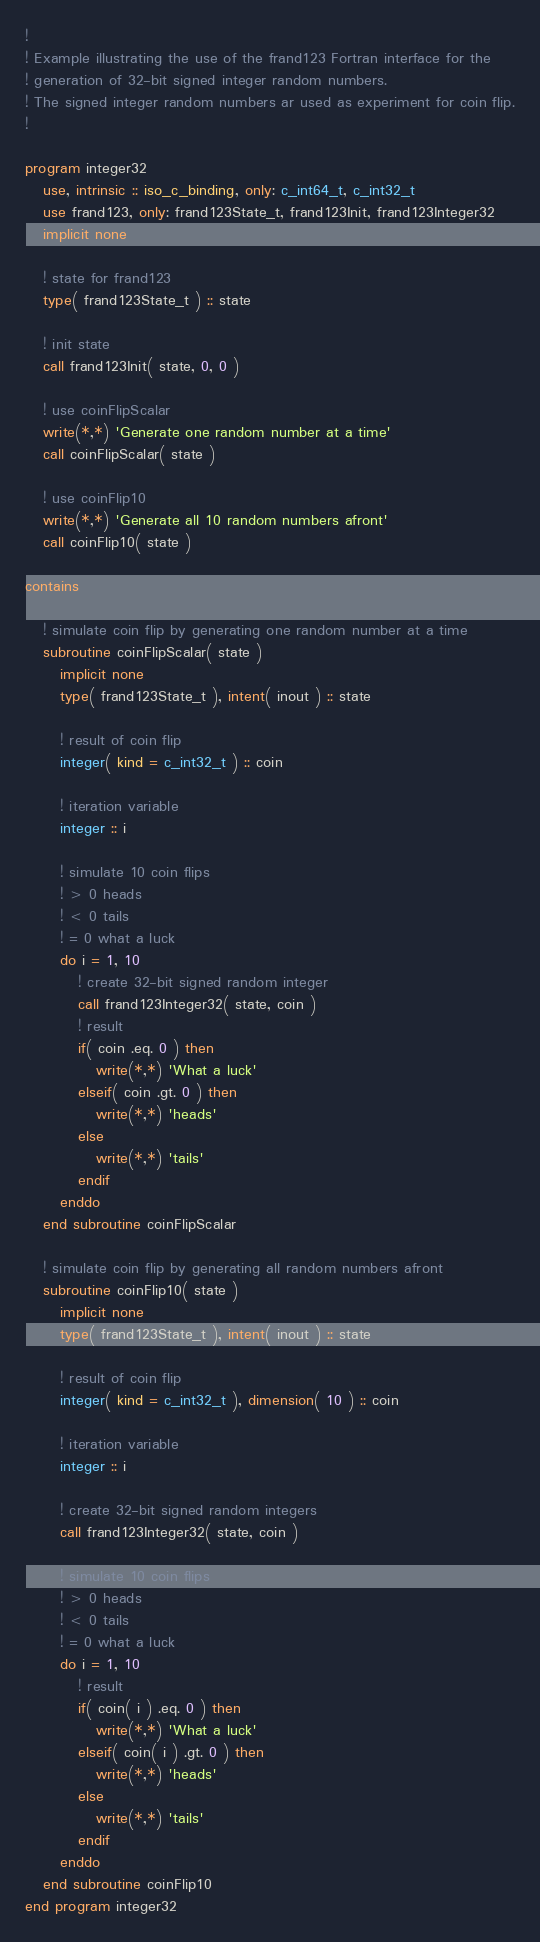<code> <loc_0><loc_0><loc_500><loc_500><_FORTRAN_>!
! Example illustrating the use of the frand123 Fortran interface for the
! generation of 32-bit signed integer random numbers.
! The signed integer random numbers ar used as experiment for coin flip.
!

program integer32
   use, intrinsic :: iso_c_binding, only: c_int64_t, c_int32_t
   use frand123, only: frand123State_t, frand123Init, frand123Integer32
   implicit none

   ! state for frand123
   type( frand123State_t ) :: state

   ! init state
   call frand123Init( state, 0, 0 )

   ! use coinFlipScalar
   write(*,*) 'Generate one random number at a time'
   call coinFlipScalar( state )

   ! use coinFlip10
   write(*,*) 'Generate all 10 random numbers afront'
   call coinFlip10( state )

contains

   ! simulate coin flip by generating one random number at a time
   subroutine coinFlipScalar( state )
      implicit none
      type( frand123State_t ), intent( inout ) :: state

      ! result of coin flip
      integer( kind = c_int32_t ) :: coin

      ! iteration variable
      integer :: i

      ! simulate 10 coin flips
      ! > 0 heads
      ! < 0 tails
      ! = 0 what a luck
      do i = 1, 10
         ! create 32-bit signed random integer
         call frand123Integer32( state, coin )
         ! result
         if( coin .eq. 0 ) then
            write(*,*) 'What a luck'
         elseif( coin .gt. 0 ) then
            write(*,*) 'heads'
         else
            write(*,*) 'tails'
         endif
      enddo
   end subroutine coinFlipScalar

   ! simulate coin flip by generating all random numbers afront
   subroutine coinFlip10( state )
      implicit none
      type( frand123State_t ), intent( inout ) :: state

      ! result of coin flip
      integer( kind = c_int32_t ), dimension( 10 ) :: coin

      ! iteration variable
      integer :: i

      ! create 32-bit signed random integers
      call frand123Integer32( state, coin )

      ! simulate 10 coin flips
      ! > 0 heads
      ! < 0 tails
      ! = 0 what a luck
      do i = 1, 10
         ! result
         if( coin( i ) .eq. 0 ) then
            write(*,*) 'What a luck'
         elseif( coin( i ) .gt. 0 ) then
            write(*,*) 'heads'
         else
            write(*,*) 'tails'
         endif
      enddo
   end subroutine coinFlip10
end program integer32
</code> 